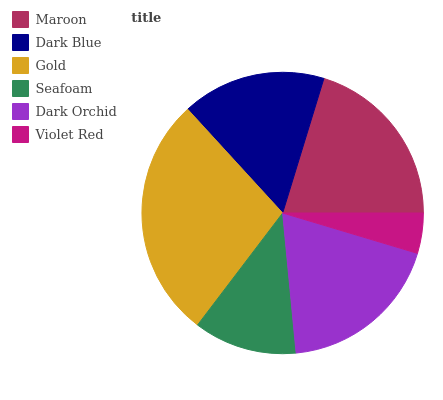Is Violet Red the minimum?
Answer yes or no. Yes. Is Gold the maximum?
Answer yes or no. Yes. Is Dark Blue the minimum?
Answer yes or no. No. Is Dark Blue the maximum?
Answer yes or no. No. Is Maroon greater than Dark Blue?
Answer yes or no. Yes. Is Dark Blue less than Maroon?
Answer yes or no. Yes. Is Dark Blue greater than Maroon?
Answer yes or no. No. Is Maroon less than Dark Blue?
Answer yes or no. No. Is Dark Orchid the high median?
Answer yes or no. Yes. Is Dark Blue the low median?
Answer yes or no. Yes. Is Gold the high median?
Answer yes or no. No. Is Gold the low median?
Answer yes or no. No. 